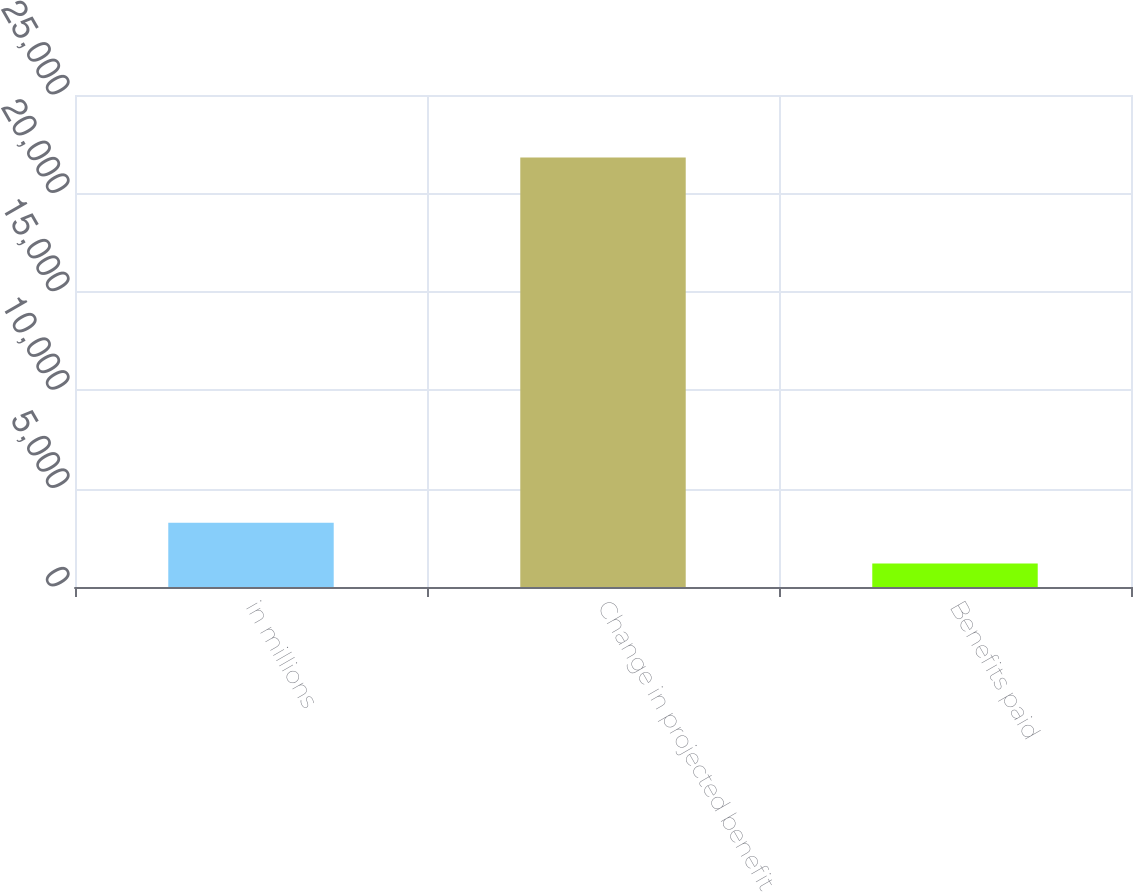Convert chart. <chart><loc_0><loc_0><loc_500><loc_500><bar_chart><fcel>in millions<fcel>Change in projected benefit<fcel>Benefits paid<nl><fcel>3259.3<fcel>21820<fcel>1197<nl></chart> 